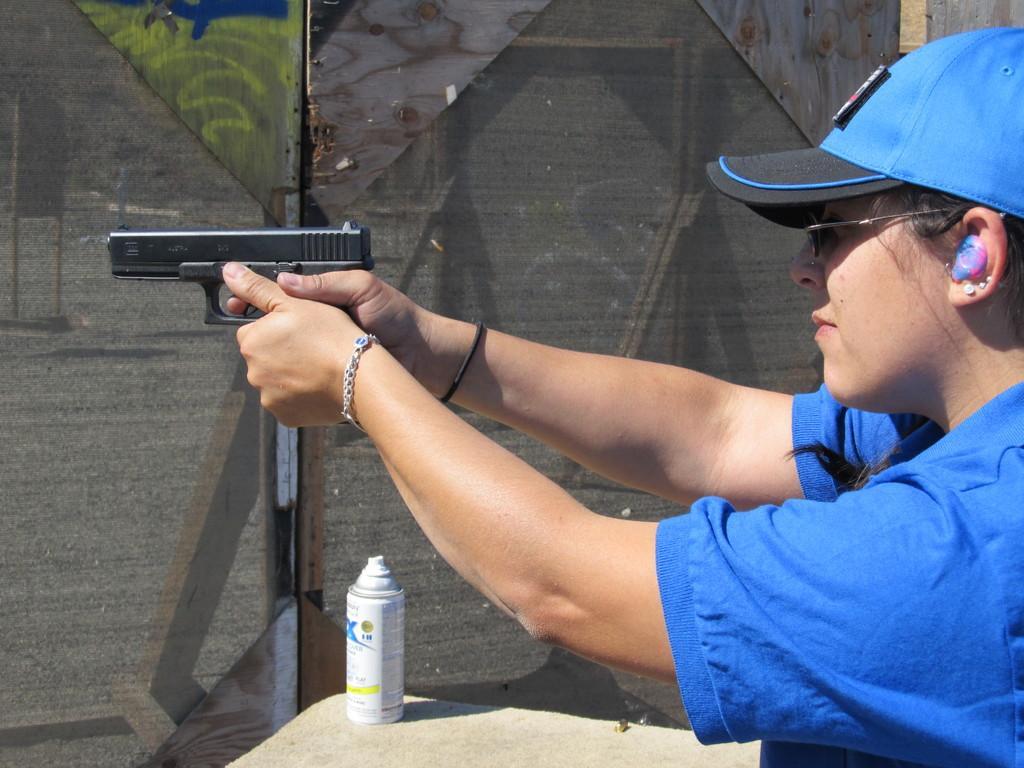In one or two sentences, can you explain what this image depicts? In this picture I can see a woman holding a gun in her hands and she is wearing a cap on her head and I can see a bottle on the table and I can see fence in the background. 